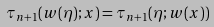<formula> <loc_0><loc_0><loc_500><loc_500>\tau _ { n + 1 } ( w ( \eta ) ; x ) = \tau _ { n + 1 } ( \eta ; w ( x ) )</formula> 